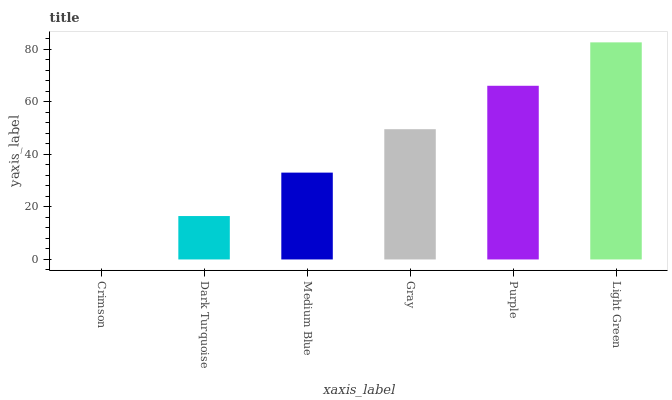Is Crimson the minimum?
Answer yes or no. Yes. Is Light Green the maximum?
Answer yes or no. Yes. Is Dark Turquoise the minimum?
Answer yes or no. No. Is Dark Turquoise the maximum?
Answer yes or no. No. Is Dark Turquoise greater than Crimson?
Answer yes or no. Yes. Is Crimson less than Dark Turquoise?
Answer yes or no. Yes. Is Crimson greater than Dark Turquoise?
Answer yes or no. No. Is Dark Turquoise less than Crimson?
Answer yes or no. No. Is Gray the high median?
Answer yes or no. Yes. Is Medium Blue the low median?
Answer yes or no. Yes. Is Dark Turquoise the high median?
Answer yes or no. No. Is Dark Turquoise the low median?
Answer yes or no. No. 